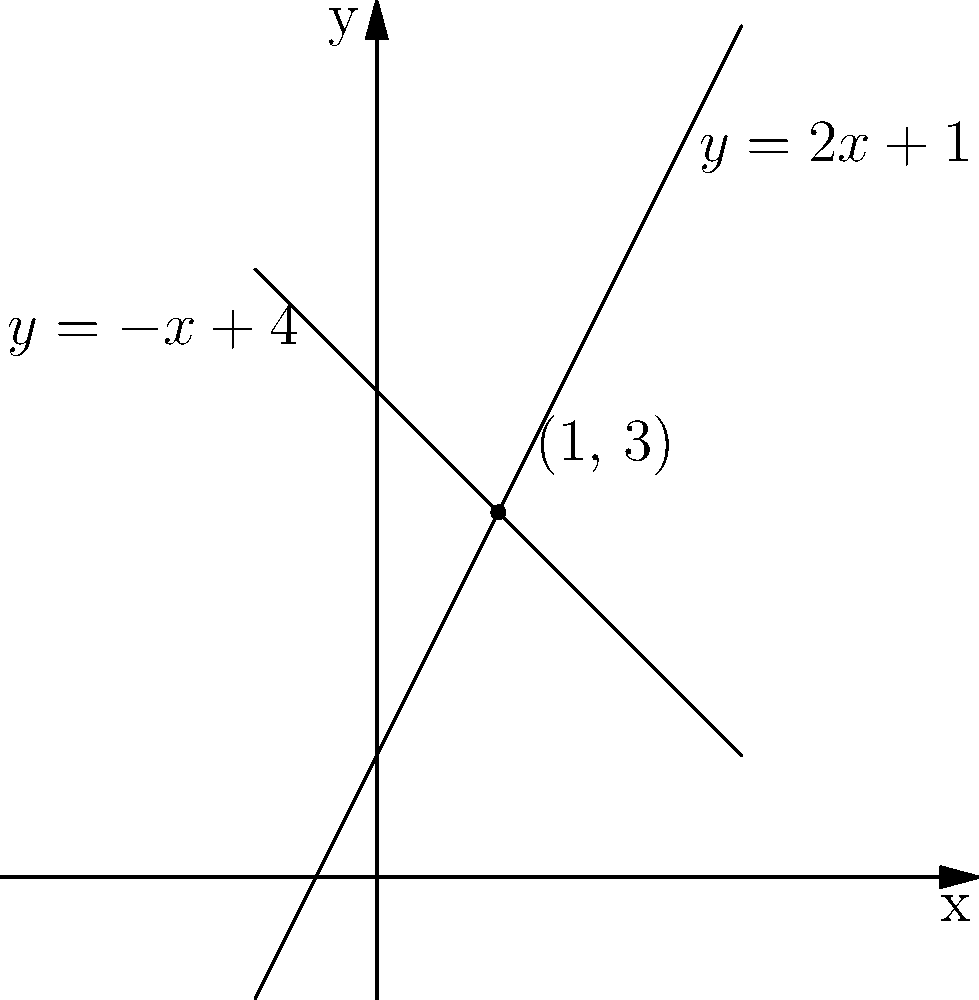As you're helping your new immigrant friend understand the local culture, you decide to use a real-life example to explain intersection points in Analytic Geometry. You draw two lines on a graph representing the popularity trends of two social media platforms over time. The equations of these lines are $y = 2x + 1$ and $y = -x + 4$. Find the intersection point of these two lines, which represents when both platforms have equal popularity. To find the intersection point of two lines, we need to solve the system of equations:

$$\begin{cases} 
y = 2x + 1 \\
y = -x + 4 
\end{cases}$$

Step 1: Since both equations equal y, we can set them equal to each other:
$2x + 1 = -x + 4$

Step 2: Add x to both sides:
$3x + 1 = 4$

Step 3: Subtract 1 from both sides:
$3x = 3$

Step 4: Divide both sides by 3:
$x = 1$

Step 5: Substitute x = 1 into either of the original equations. Let's use $y = 2x + 1$:
$y = 2(1) + 1 = 3$

Therefore, the intersection point is (1, 3).
Answer: (1, 3) 